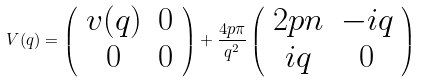Convert formula to latex. <formula><loc_0><loc_0><loc_500><loc_500>V ( { q } ) = \left ( \begin{array} { c c } v ( q ) & 0 \\ 0 & 0 \end{array} \right ) + \frac { 4 p \pi } { q ^ { 2 } } \left ( \begin{array} { c c } 2 p n & - i q \\ i q & 0 \end{array} \right )</formula> 